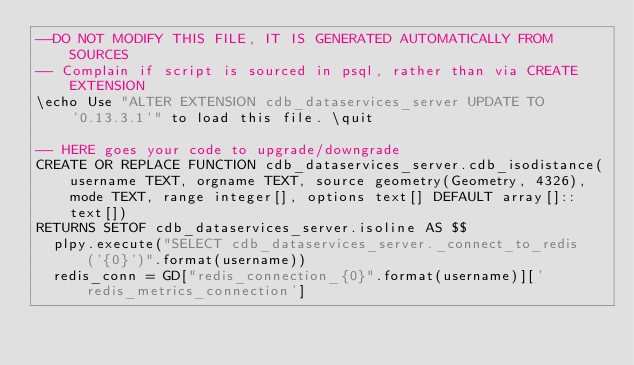<code> <loc_0><loc_0><loc_500><loc_500><_SQL_>--DO NOT MODIFY THIS FILE, IT IS GENERATED AUTOMATICALLY FROM SOURCES
-- Complain if script is sourced in psql, rather than via CREATE EXTENSION
\echo Use "ALTER EXTENSION cdb_dataservices_server UPDATE TO '0.13.3.1'" to load this file. \quit

-- HERE goes your code to upgrade/downgrade
CREATE OR REPLACE FUNCTION cdb_dataservices_server.cdb_isodistance(username TEXT, orgname TEXT, source geometry(Geometry, 4326), mode TEXT, range integer[], options text[] DEFAULT array[]::text[])
RETURNS SETOF cdb_dataservices_server.isoline AS $$
  plpy.execute("SELECT cdb_dataservices_server._connect_to_redis('{0}')".format(username))
  redis_conn = GD["redis_connection_{0}".format(username)]['redis_metrics_connection']</code> 